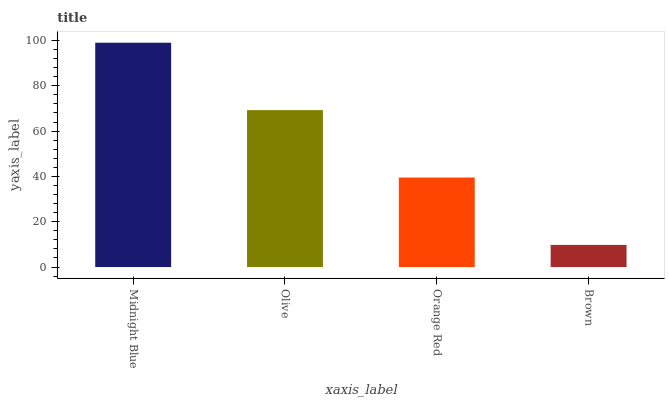Is Brown the minimum?
Answer yes or no. Yes. Is Midnight Blue the maximum?
Answer yes or no. Yes. Is Olive the minimum?
Answer yes or no. No. Is Olive the maximum?
Answer yes or no. No. Is Midnight Blue greater than Olive?
Answer yes or no. Yes. Is Olive less than Midnight Blue?
Answer yes or no. Yes. Is Olive greater than Midnight Blue?
Answer yes or no. No. Is Midnight Blue less than Olive?
Answer yes or no. No. Is Olive the high median?
Answer yes or no. Yes. Is Orange Red the low median?
Answer yes or no. Yes. Is Brown the high median?
Answer yes or no. No. Is Brown the low median?
Answer yes or no. No. 